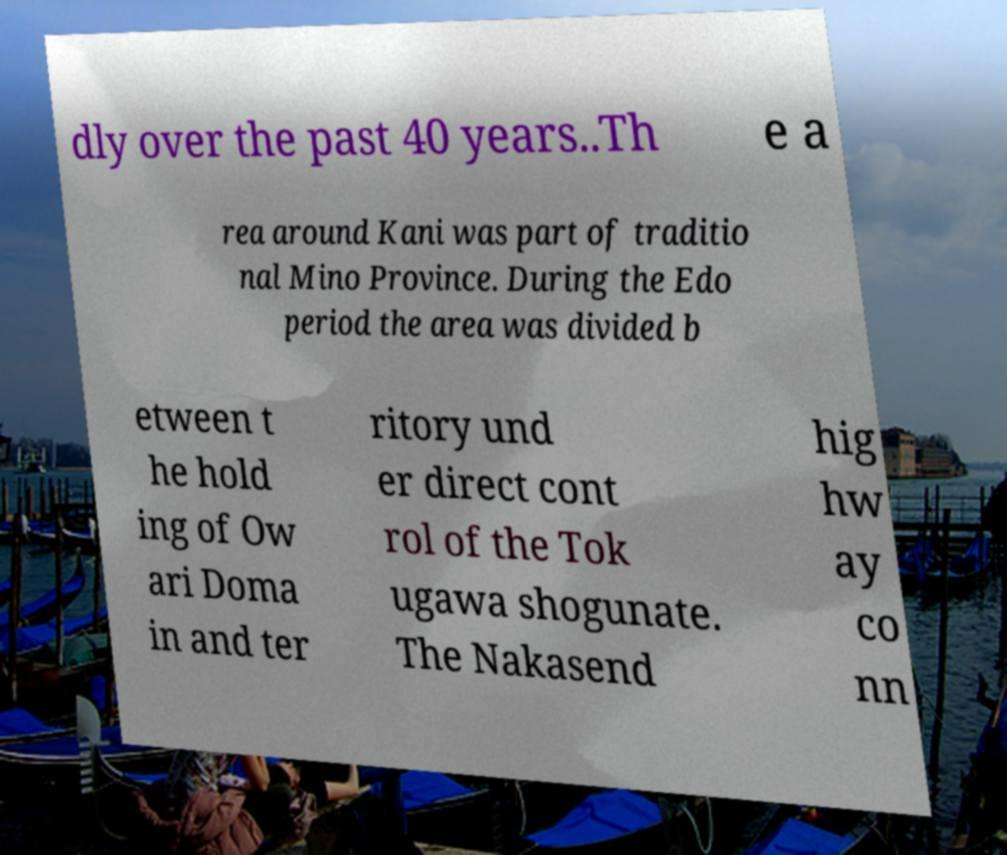There's text embedded in this image that I need extracted. Can you transcribe it verbatim? dly over the past 40 years..Th e a rea around Kani was part of traditio nal Mino Province. During the Edo period the area was divided b etween t he hold ing of Ow ari Doma in and ter ritory und er direct cont rol of the Tok ugawa shogunate. The Nakasend hig hw ay co nn 